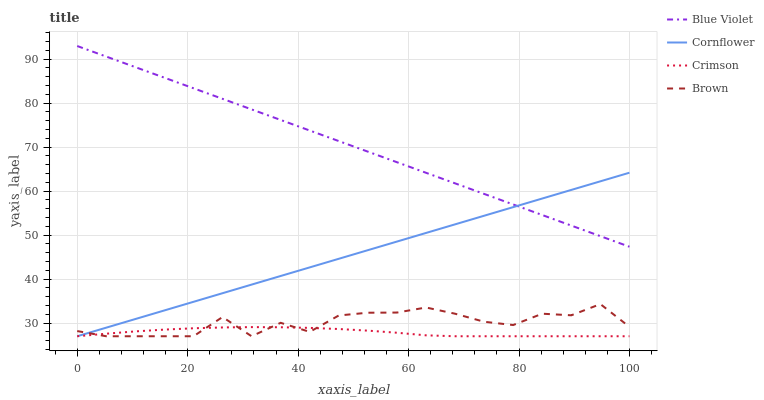Does Crimson have the minimum area under the curve?
Answer yes or no. Yes. Does Blue Violet have the maximum area under the curve?
Answer yes or no. Yes. Does Cornflower have the minimum area under the curve?
Answer yes or no. No. Does Cornflower have the maximum area under the curve?
Answer yes or no. No. Is Cornflower the smoothest?
Answer yes or no. Yes. Is Brown the roughest?
Answer yes or no. Yes. Is Blue Violet the smoothest?
Answer yes or no. No. Is Blue Violet the roughest?
Answer yes or no. No. Does Crimson have the lowest value?
Answer yes or no. Yes. Does Blue Violet have the lowest value?
Answer yes or no. No. Does Blue Violet have the highest value?
Answer yes or no. Yes. Does Cornflower have the highest value?
Answer yes or no. No. Is Brown less than Blue Violet?
Answer yes or no. Yes. Is Blue Violet greater than Brown?
Answer yes or no. Yes. Does Brown intersect Cornflower?
Answer yes or no. Yes. Is Brown less than Cornflower?
Answer yes or no. No. Is Brown greater than Cornflower?
Answer yes or no. No. Does Brown intersect Blue Violet?
Answer yes or no. No. 